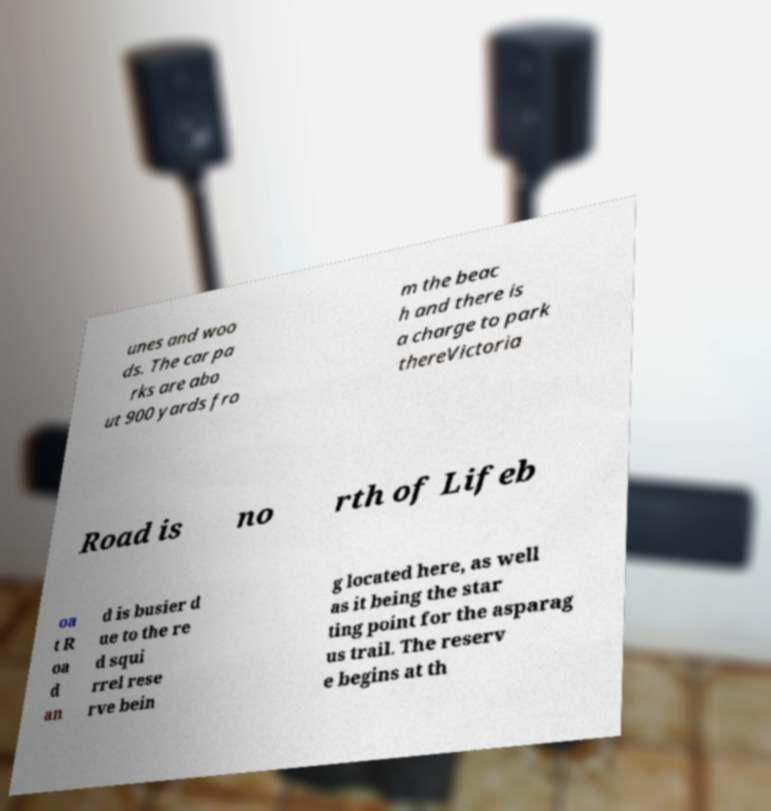For documentation purposes, I need the text within this image transcribed. Could you provide that? unes and woo ds. The car pa rks are abo ut 900 yards fro m the beac h and there is a charge to park thereVictoria Road is no rth of Lifeb oa t R oa d an d is busier d ue to the re d squi rrel rese rve bein g located here, as well as it being the star ting point for the asparag us trail. The reserv e begins at th 